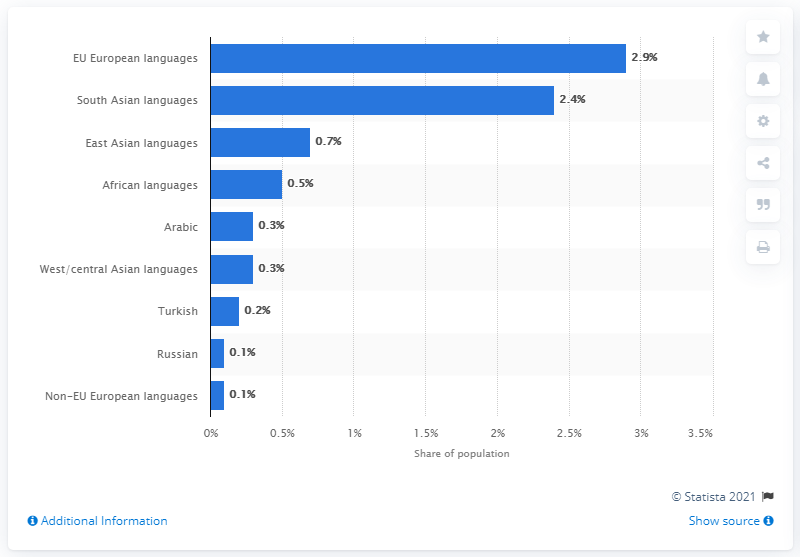Outline some significant characteristics in this image. According to the data, 2.4% of the population spoke a South Asian language as their first language. 